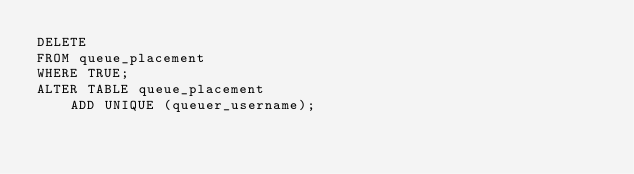<code> <loc_0><loc_0><loc_500><loc_500><_SQL_>DELETE
FROM queue_placement
WHERE TRUE;
ALTER TABLE queue_placement
    ADD UNIQUE (queuer_username);
</code> 